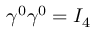<formula> <loc_0><loc_0><loc_500><loc_500>\gamma ^ { 0 } \gamma ^ { 0 } = I _ { 4 }</formula> 